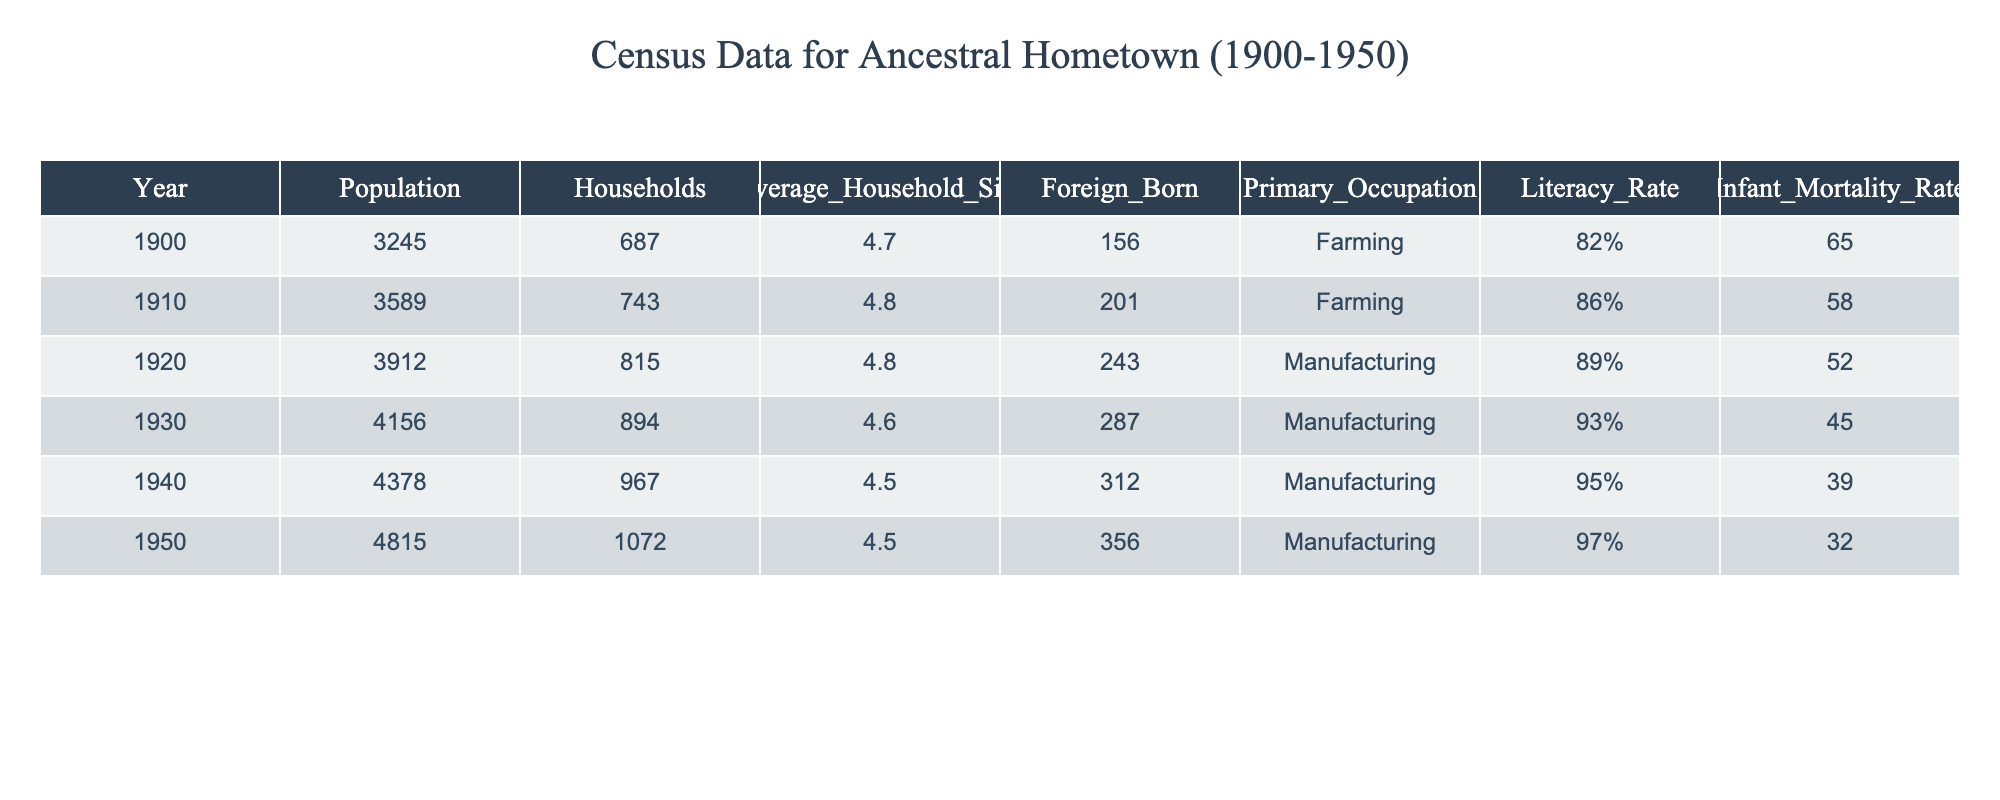What was the population in 1910? The table shows that the population in 1910 was listed directly under the "Population" column for the year 1910, which is 3589.
Answer: 3589 What was the average household size in 1940? By referring to the "Average_Household_Size" column for the year 1940, the value is 4.5.
Answer: 4.5 What was the literacy rate in 1920? The literacy rate for the year 1920 can be found in the "Literacy_Rate" column, which is 89%.
Answer: 89% How many foreign-born individuals were there in 1950? The number of foreign-born individuals for the year 1950 is found in the "Foreign_Born" column, which is 356.
Answer: 356 What was the change in population from 1900 to 1950? To find the change in population, subtract the 1900 population (3245) from the 1950 population (4815): 4815 - 3245 = 1570.
Answer: 1570 What is the average infant mortality rate from 1900 to 1950? The infant mortality rates across the years are 65, 58, 52, 45, 39, 32. To find the average, sum these values (65 + 58 + 52 + 45 + 39 + 32 = 291) and divide by 6, which results in an average of 48.5.
Answer: 48.5 Did the primary occupation change from farming to manufacturing between 1920 and 1950? In 1920, the primary occupation was manufacturing, while in 1950 it remained manufacturing. Therefore, the primary occupation did not change.
Answer: No What was the percentage increase in the literacy rate from 1900 to 1950? To calculate the percentage increase, subtract the 1900 literacy rate (82%) from the 1950 literacy rate (97%): 97% - 82% = 15%. Then divide this increase by the original rate (82%) and multiply by 100 to get the percentage increase: (15 / 82) * 100 = 18.29%.
Answer: 18.29% Was the infant mortality rate lower in 1950 than in 1900? The infant mortality rate in 1900 was 65, and in 1950 it was 32. Since 32 is less than 65, the infant mortality rate was lower in 1950.
Answer: Yes What was the household count increase from 1930 to 1940? The number of households in 1930 was 894 and in 1940 was 967. To determine the increase, subtract the 1930 households from 1940 households: 967 - 894 = 73.
Answer: 73 